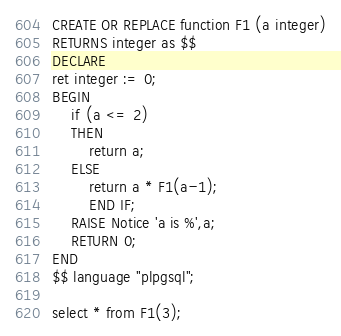<code> <loc_0><loc_0><loc_500><loc_500><_SQL_>CREATE OR REPLACE function F1 (a integer)
RETURNS integer as $$
DECLARE
ret integer := 0;
BEGIN
	if (a <= 2)
	THEN
		return a;
	ELSE
		return a * F1(a-1);
		END IF;
	RAISE Notice 'a is %',a;
	RETURN 0;
END
$$ language "plpgsql";

select * from F1(3);
</code> 